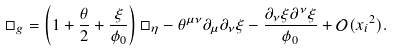<formula> <loc_0><loc_0><loc_500><loc_500>\Box _ { g } = \left ( 1 + \frac { \theta } { 2 } + \frac { \xi } { \phi _ { 0 } } \right ) \Box _ { \eta } - \theta ^ { \mu \nu } \partial _ { \mu } \partial _ { \nu } \xi - \frac { \partial _ { \nu } \xi \partial ^ { \nu } \xi } { \phi _ { 0 } } + \mathcal { O } { ( { x _ { i } } ^ { 2 } ) } .</formula> 